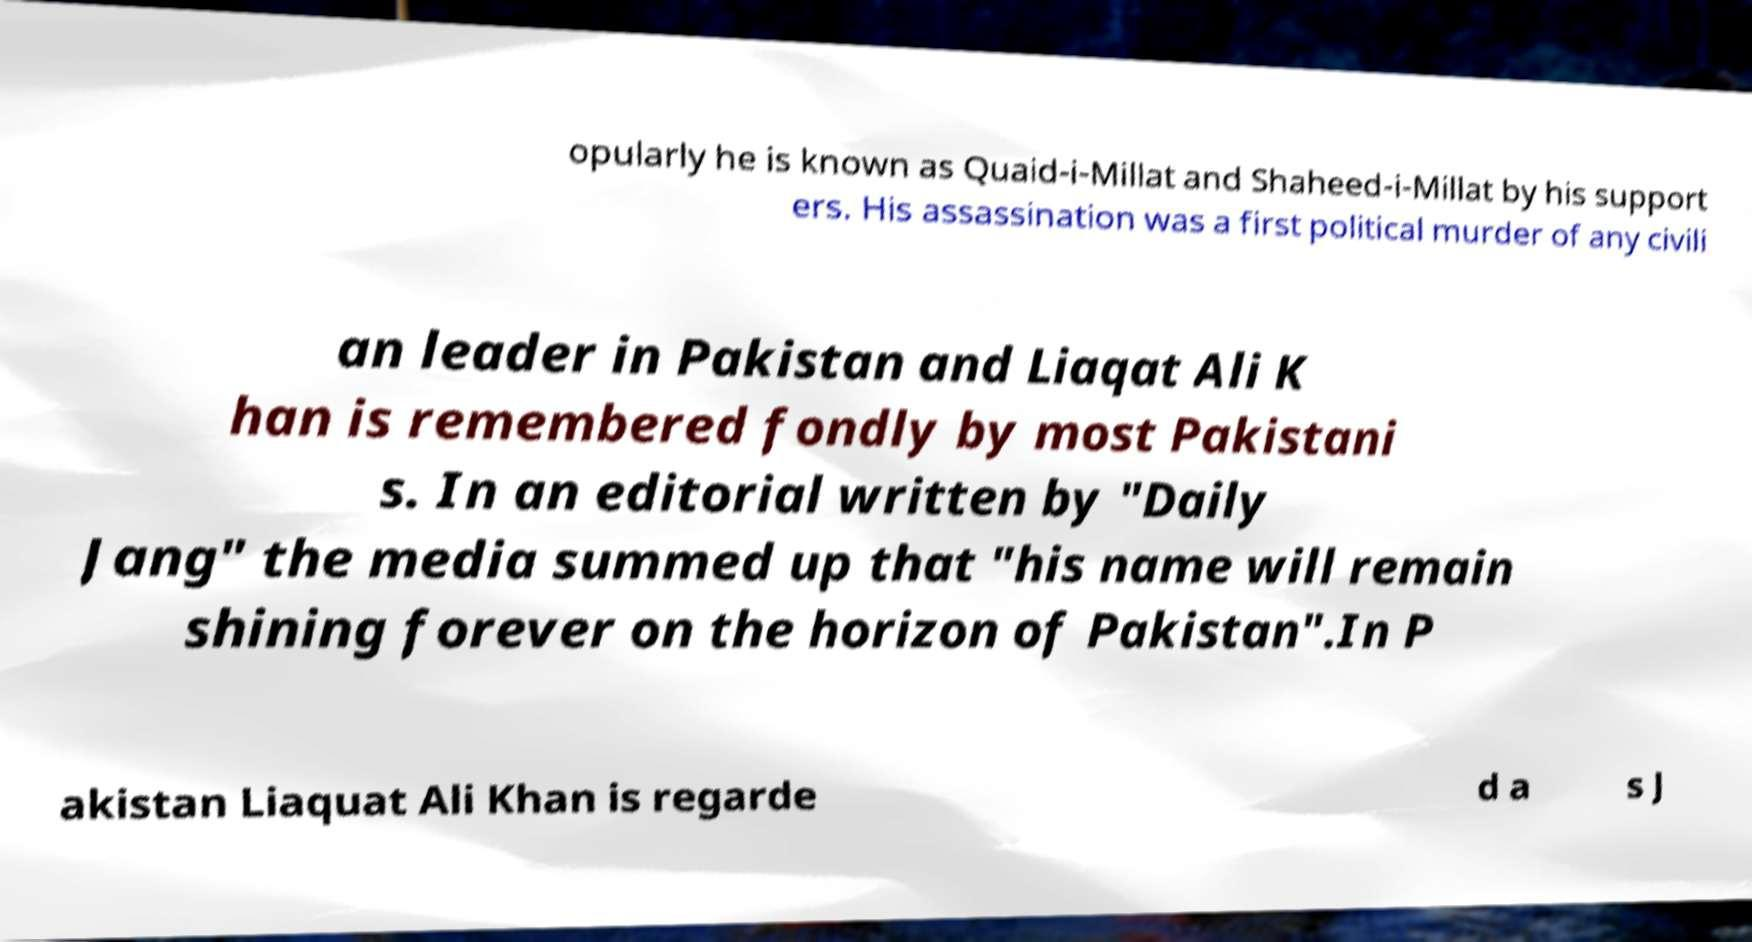Could you extract and type out the text from this image? opularly he is known as Quaid-i-Millat and Shaheed-i-Millat by his support ers. His assassination was a first political murder of any civili an leader in Pakistan and Liaqat Ali K han is remembered fondly by most Pakistani s. In an editorial written by "Daily Jang" the media summed up that "his name will remain shining forever on the horizon of Pakistan".In P akistan Liaquat Ali Khan is regarde d a s J 